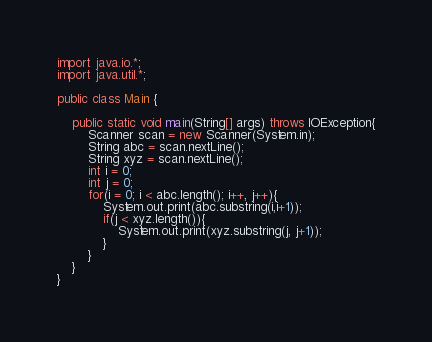Convert code to text. <code><loc_0><loc_0><loc_500><loc_500><_Java_>import java.io.*;
import java.util.*;

public class Main {

	public static void main(String[] args) throws IOException{
		Scanner scan = new Scanner(System.in);
		String abc = scan.nextLine();
		String xyz = scan.nextLine();
		int i = 0;
		int j = 0;
		for(i = 0; i < abc.length(); i++, j++){
			System.out.print(abc.substring(i,i+1));
			if(j < xyz.length()){
				System.out.print(xyz.substring(j, j+1));
			}
		}
	}
}
</code> 